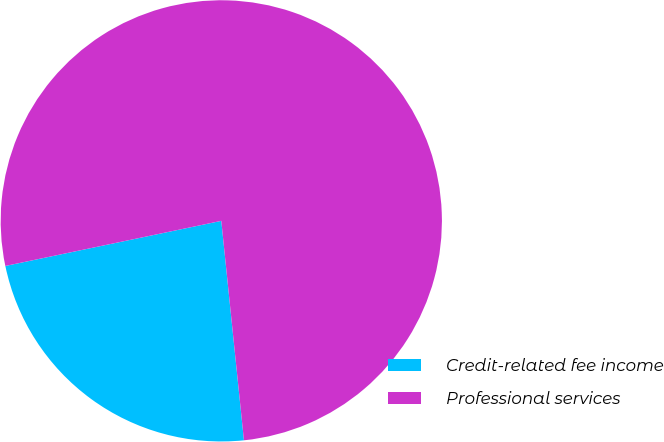Convert chart. <chart><loc_0><loc_0><loc_500><loc_500><pie_chart><fcel>Credit-related fee income<fcel>Professional services<nl><fcel>23.36%<fcel>76.64%<nl></chart> 